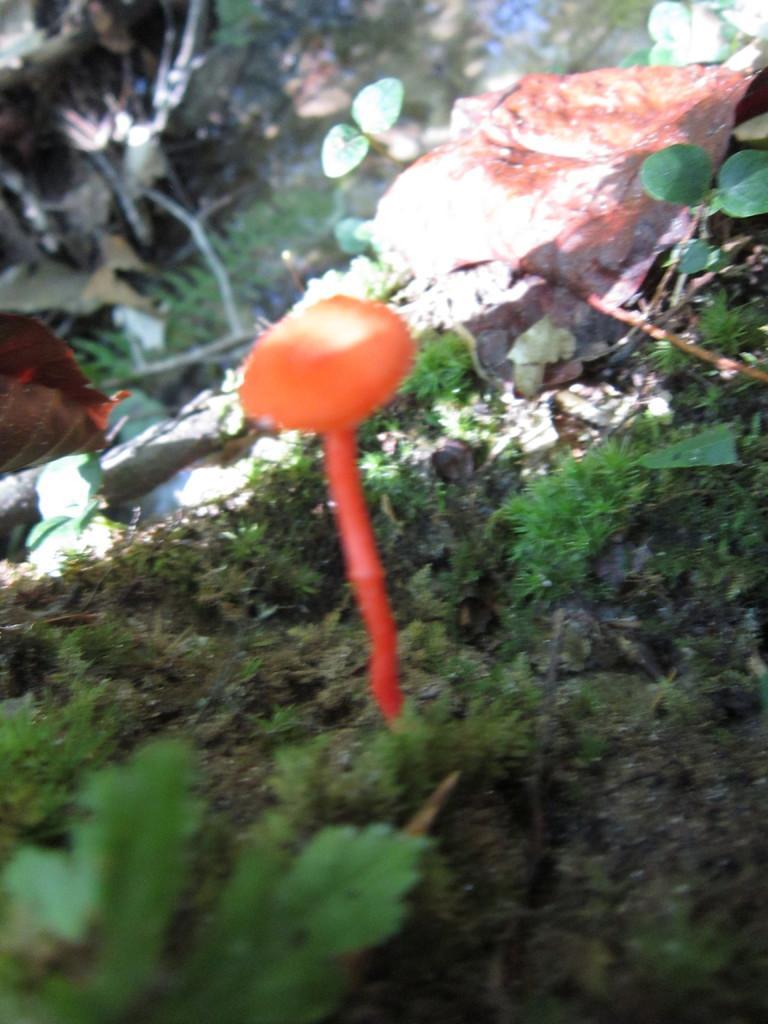Can you describe this image briefly? In the center of the image we can see a fish in the water and there are leaves. At the bottom there is grass. 